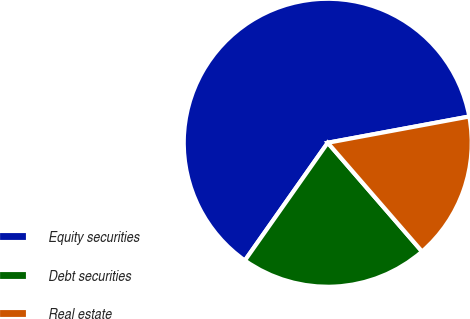Convert chart. <chart><loc_0><loc_0><loc_500><loc_500><pie_chart><fcel>Equity securities<fcel>Debt securities<fcel>Real estate<nl><fcel>62.32%<fcel>21.13%<fcel>16.55%<nl></chart> 